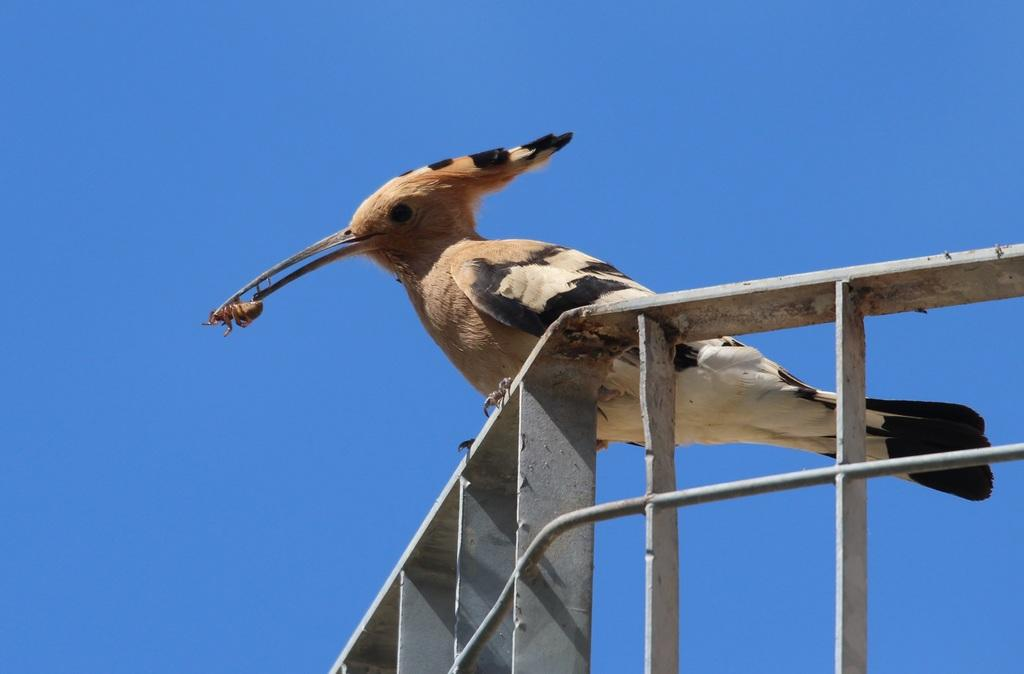What type of animal can be seen in the image? There is a bird in the image. Where is the bird located? The bird is on an iron grille. What is the bird holding in its beak? The bird is holding an insect. What can be seen in the background of the image? The sky is visible in the background of the image. Is the writer visible in the image? There is no writer present in the image; it features a bird on an iron grille holding an insect. Can you see any mist in the image? There is no mist visible in the image; it shows a bird on an iron grille holding an insect with the sky in the background. 